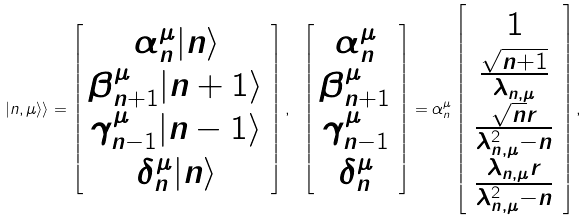<formula> <loc_0><loc_0><loc_500><loc_500>| n , \mu \rangle \rangle = \left [ \begin{array} { c } \alpha _ { n } ^ { \mu } | n \rangle \\ \beta _ { n + 1 } ^ { \mu } | n + 1 \rangle \\ \gamma _ { n - 1 } ^ { \mu } | n - 1 \rangle \\ \delta _ { n } ^ { \mu } | n \rangle \end{array} \right ] , \ \left [ \begin{array} { c } \alpha _ { n } ^ { \mu } \\ \beta _ { n + 1 } ^ { \mu } \\ \gamma _ { n - 1 } ^ { \mu } \\ \delta _ { n } ^ { \mu } \end{array} \right ] = \alpha _ { n } ^ { \mu } \left [ \begin{array} { c } 1 \\ \frac { \sqrt { n + 1 } } { \lambda _ { n , \mu } } \\ \frac { \sqrt { n } r } { \lambda _ { n , \mu } ^ { 2 } - n } \\ \frac { \lambda _ { n , \mu } r } { \lambda _ { n , \mu } ^ { 2 } - n } \end{array} \right ] ,</formula> 